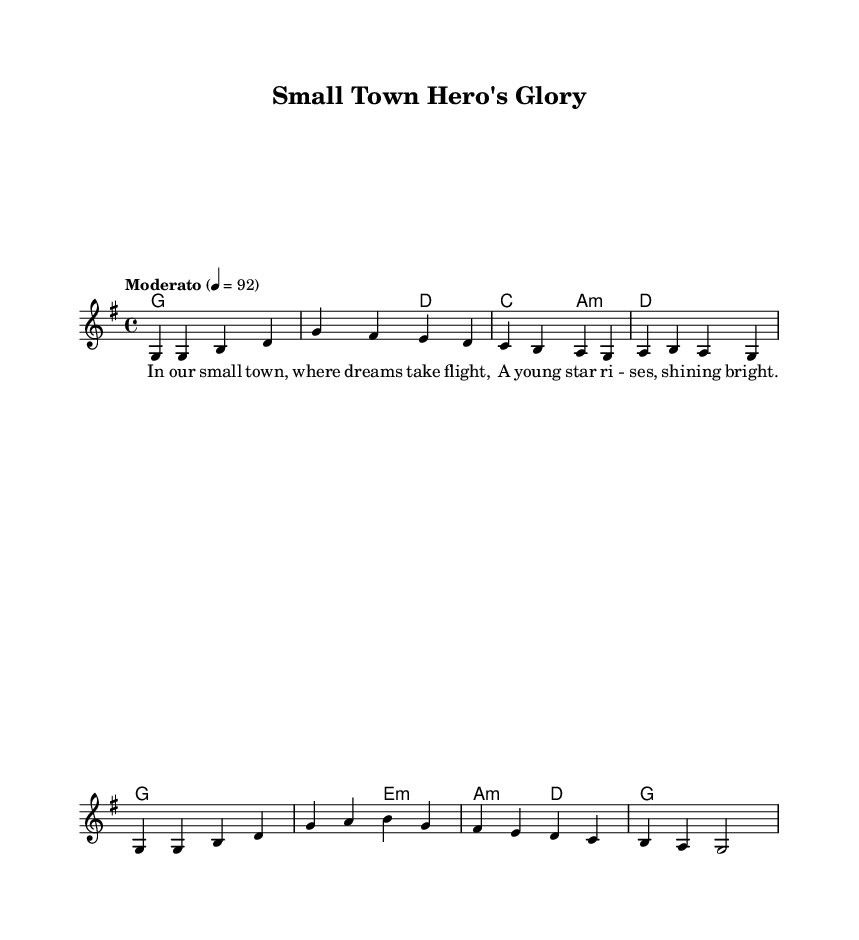What is the key signature of this music? The key signature is G major, which has one sharp (F#). This can be deduced from the global section of the code where it specifies `\key g \major`.
Answer: G major What is the time signature of this music? The time signature is 4/4, which indicates that there are four beats in a measure and each beat is a quarter note. This is stated in the global section of the code with `\time 4/4`.
Answer: 4/4 What is the tempo marking of this piece? The tempo marking is "Moderato" with a metronome marking of 92 beats per minute. This is highlighted in the global section where it specifies `\tempo "Moderato" 4 = 92`.
Answer: Moderato How many measures are in the melody? The melody consists of 8 measures. This can be counted visually in the given melody section, where each line contains a specific number of notes corresponding to the measures.
Answer: 8 What are the primary chords used in the harmonies? The primary chords used are G, D, C, and A minor. These are visible in the harmonies section where they are explicitly shown as chord names.
Answer: G, D, C, A minor What themes are highlighted in the lyrics of the first verse? The themes highlighted are dreams and youth, emphasizing rising stars in a small town context. This is derived from the content of the verse provided in the lyrics section.
Answer: Dreams, youth What genre does this piece belong to? This piece belongs to the Folk genre, as specified, which often includes traditional themes and storytelling aspects about small-town experiences and heroes.
Answer: Folk 